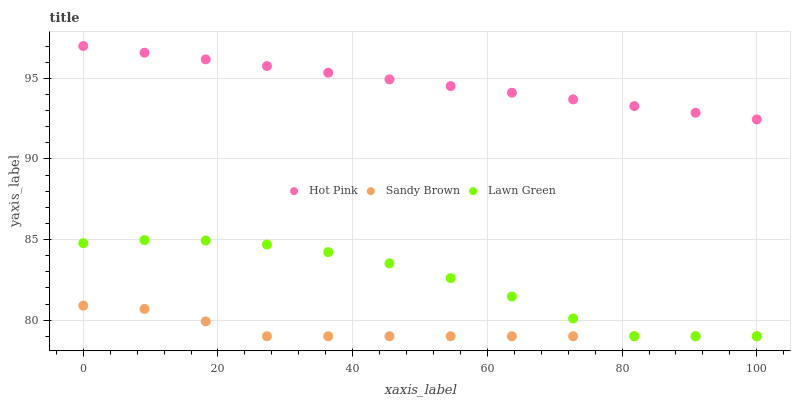Does Sandy Brown have the minimum area under the curve?
Answer yes or no. Yes. Does Hot Pink have the maximum area under the curve?
Answer yes or no. Yes. Does Hot Pink have the minimum area under the curve?
Answer yes or no. No. Does Sandy Brown have the maximum area under the curve?
Answer yes or no. No. Is Hot Pink the smoothest?
Answer yes or no. Yes. Is Lawn Green the roughest?
Answer yes or no. Yes. Is Sandy Brown the smoothest?
Answer yes or no. No. Is Sandy Brown the roughest?
Answer yes or no. No. Does Lawn Green have the lowest value?
Answer yes or no. Yes. Does Hot Pink have the lowest value?
Answer yes or no. No. Does Hot Pink have the highest value?
Answer yes or no. Yes. Does Sandy Brown have the highest value?
Answer yes or no. No. Is Sandy Brown less than Hot Pink?
Answer yes or no. Yes. Is Hot Pink greater than Lawn Green?
Answer yes or no. Yes. Does Sandy Brown intersect Lawn Green?
Answer yes or no. Yes. Is Sandy Brown less than Lawn Green?
Answer yes or no. No. Is Sandy Brown greater than Lawn Green?
Answer yes or no. No. Does Sandy Brown intersect Hot Pink?
Answer yes or no. No. 